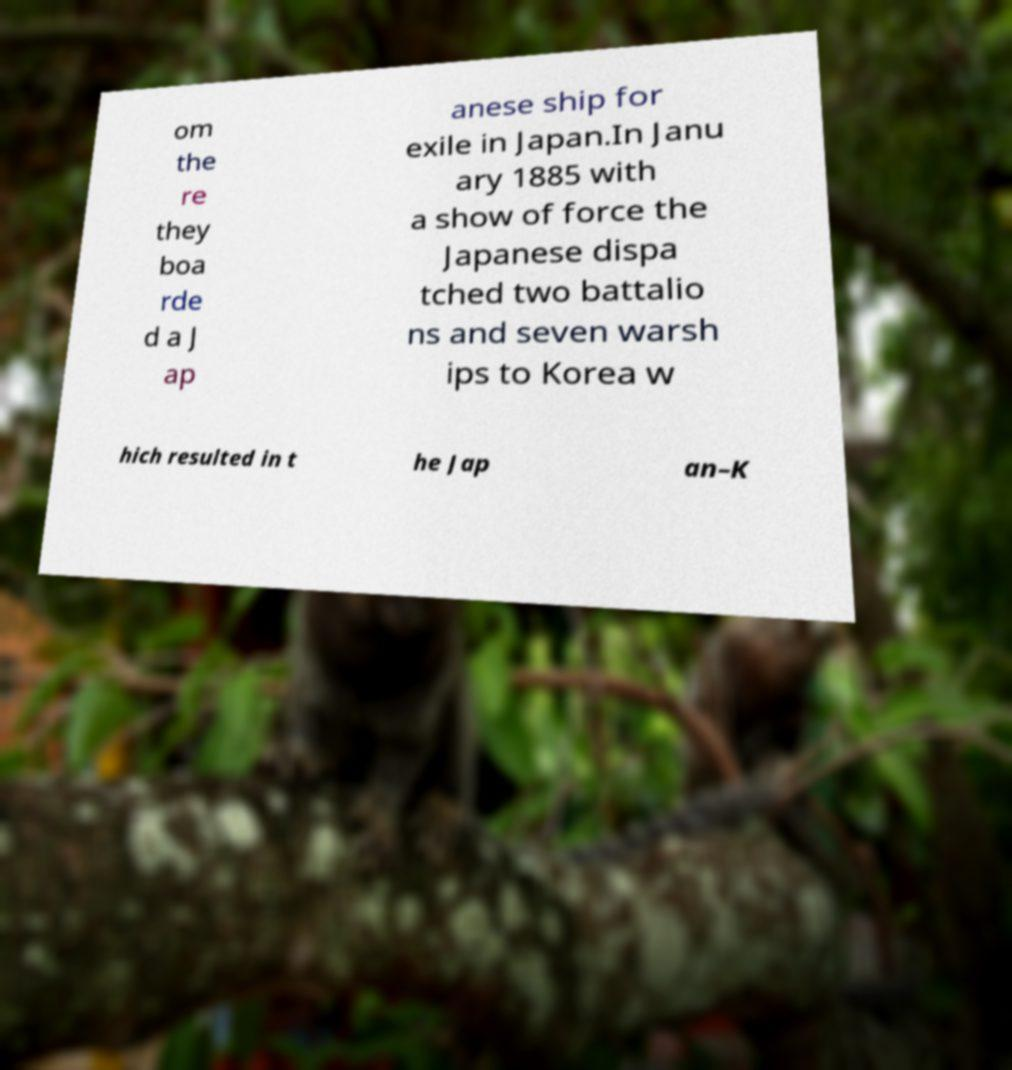Please read and relay the text visible in this image. What does it say? om the re they boa rde d a J ap anese ship for exile in Japan.In Janu ary 1885 with a show of force the Japanese dispa tched two battalio ns and seven warsh ips to Korea w hich resulted in t he Jap an–K 